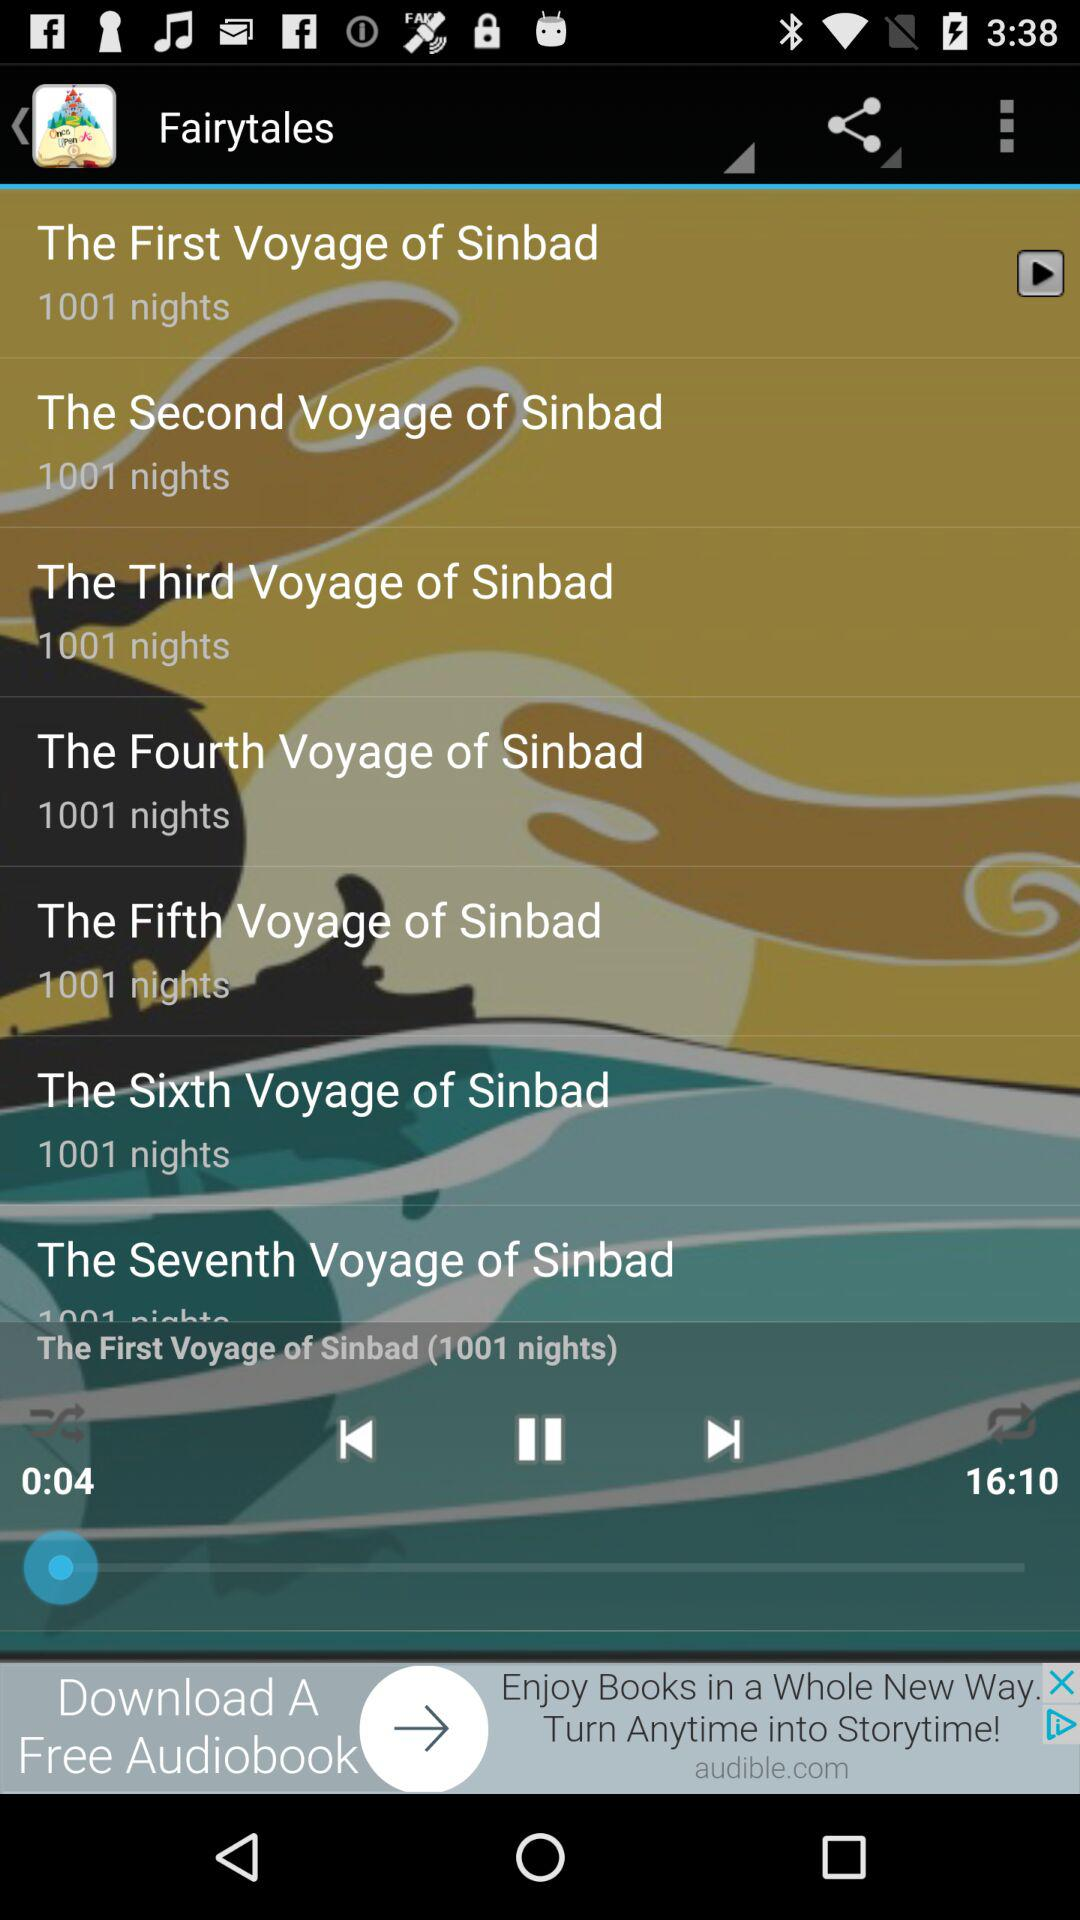What is the duration of the audio? The duration of the audio is 16 minutes and 10 seconds. 